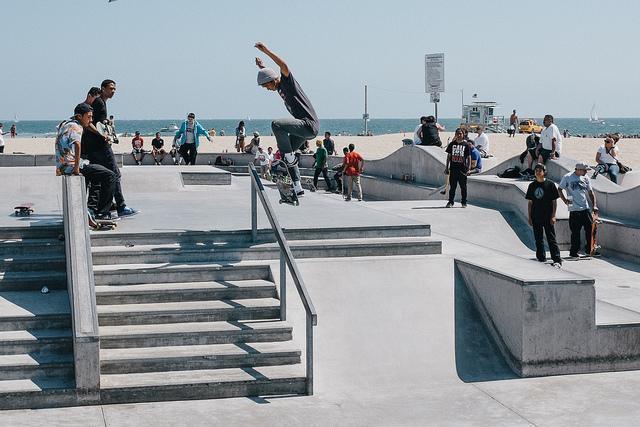How many people are in the picture?
Give a very brief answer. 5. 